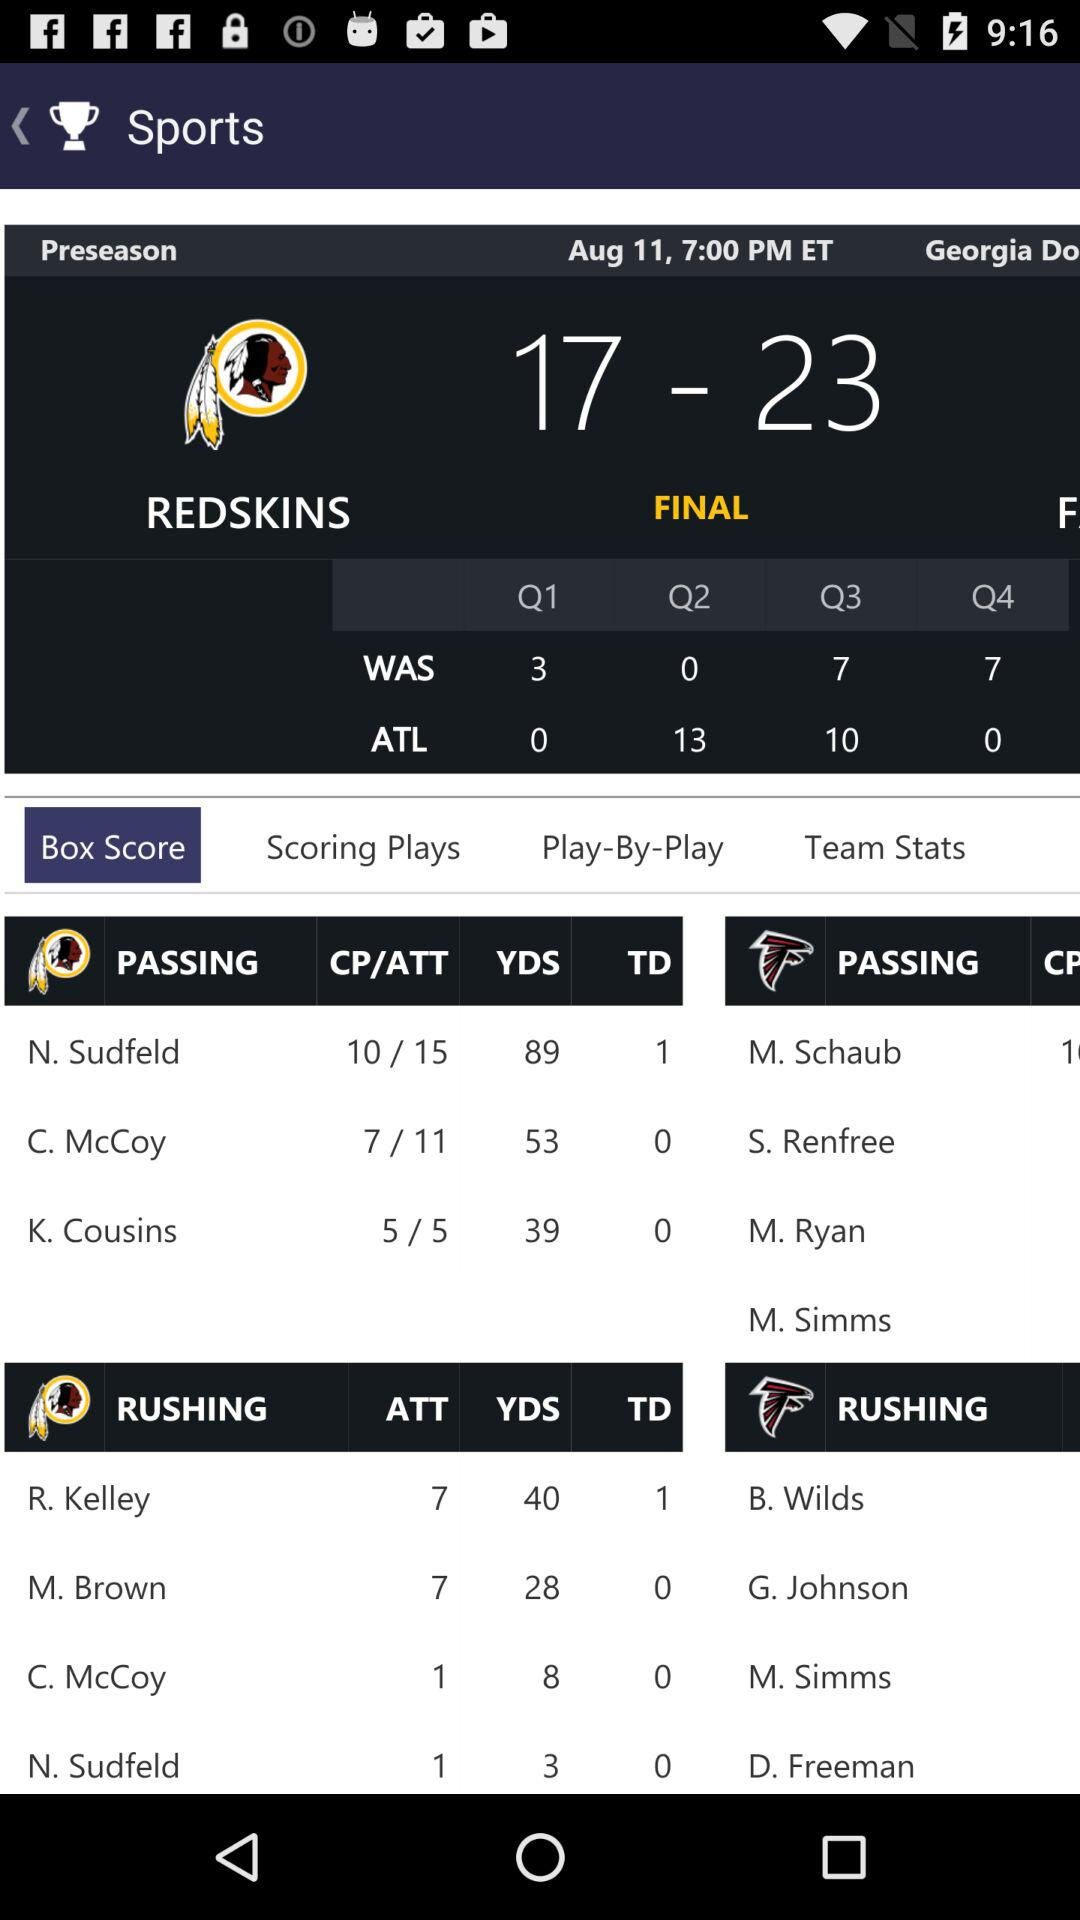Which player has a CP/ATT value of 10/15? The player is N. Sudfeld. 